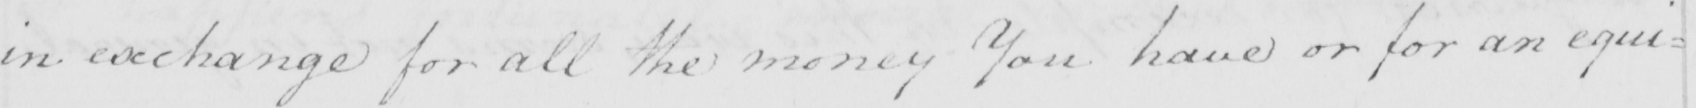What text is written in this handwritten line? in exchange for all the money You have or for an equi= 